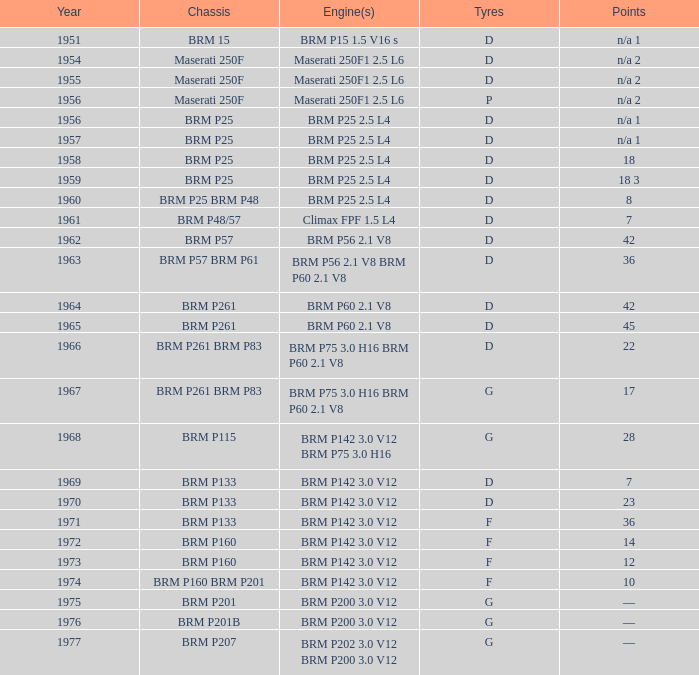Can you mention a key highlight from 1974? 10.0. Can you parse all the data within this table? {'header': ['Year', 'Chassis', 'Engine(s)', 'Tyres', 'Points'], 'rows': [['1951', 'BRM 15', 'BRM P15 1.5 V16 s', 'D', 'n/a 1'], ['1954', 'Maserati 250F', 'Maserati 250F1 2.5 L6', 'D', 'n/a 2'], ['1955', 'Maserati 250F', 'Maserati 250F1 2.5 L6', 'D', 'n/a 2'], ['1956', 'Maserati 250F', 'Maserati 250F1 2.5 L6', 'P', 'n/a 2'], ['1956', 'BRM P25', 'BRM P25 2.5 L4', 'D', 'n/a 1'], ['1957', 'BRM P25', 'BRM P25 2.5 L4', 'D', 'n/a 1'], ['1958', 'BRM P25', 'BRM P25 2.5 L4', 'D', '18'], ['1959', 'BRM P25', 'BRM P25 2.5 L4', 'D', '18 3'], ['1960', 'BRM P25 BRM P48', 'BRM P25 2.5 L4', 'D', '8'], ['1961', 'BRM P48/57', 'Climax FPF 1.5 L4', 'D', '7'], ['1962', 'BRM P57', 'BRM P56 2.1 V8', 'D', '42'], ['1963', 'BRM P57 BRM P61', 'BRM P56 2.1 V8 BRM P60 2.1 V8', 'D', '36'], ['1964', 'BRM P261', 'BRM P60 2.1 V8', 'D', '42'], ['1965', 'BRM P261', 'BRM P60 2.1 V8', 'D', '45'], ['1966', 'BRM P261 BRM P83', 'BRM P75 3.0 H16 BRM P60 2.1 V8', 'D', '22'], ['1967', 'BRM P261 BRM P83', 'BRM P75 3.0 H16 BRM P60 2.1 V8', 'G', '17'], ['1968', 'BRM P115', 'BRM P142 3.0 V12 BRM P75 3.0 H16', 'G', '28'], ['1969', 'BRM P133', 'BRM P142 3.0 V12', 'D', '7'], ['1970', 'BRM P133', 'BRM P142 3.0 V12', 'D', '23'], ['1971', 'BRM P133', 'BRM P142 3.0 V12', 'F', '36'], ['1972', 'BRM P160', 'BRM P142 3.0 V12', 'F', '14'], ['1973', 'BRM P160', 'BRM P142 3.0 V12', 'F', '12'], ['1974', 'BRM P160 BRM P201', 'BRM P142 3.0 V12', 'F', '10'], ['1975', 'BRM P201', 'BRM P200 3.0 V12', 'G', '—'], ['1976', 'BRM P201B', 'BRM P200 3.0 V12', 'G', '—'], ['1977', 'BRM P207', 'BRM P202 3.0 V12 BRM P200 3.0 V12', 'G', '—']]} 